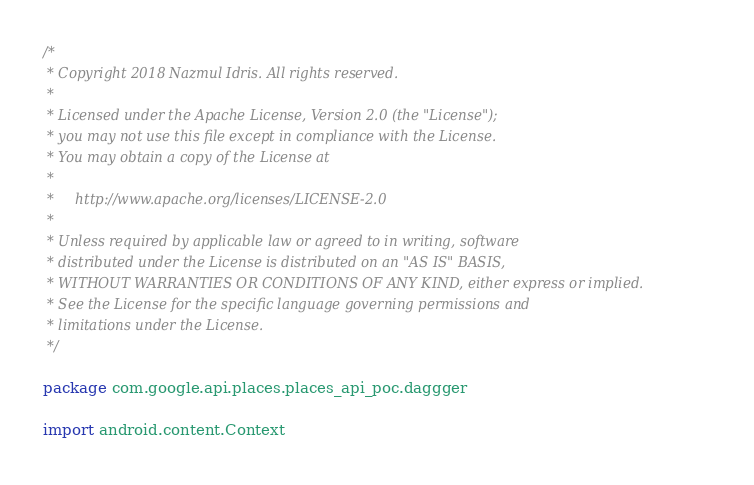Convert code to text. <code><loc_0><loc_0><loc_500><loc_500><_Kotlin_>/*
 * Copyright 2018 Nazmul Idris. All rights reserved.
 *
 * Licensed under the Apache License, Version 2.0 (the "License");
 * you may not use this file except in compliance with the License.
 * You may obtain a copy of the License at
 *
 *     http://www.apache.org/licenses/LICENSE-2.0
 *
 * Unless required by applicable law or agreed to in writing, software
 * distributed under the License is distributed on an "AS IS" BASIS,
 * WITHOUT WARRANTIES OR CONDITIONS OF ANY KIND, either express or implied.
 * See the License for the specific language governing permissions and
 * limitations under the License.
 */

package com.google.api.places.places_api_poc.daggger

import android.content.Context</code> 